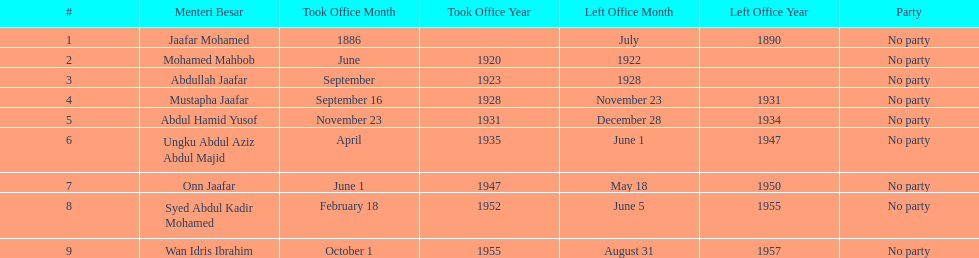Other than abullah jaafar, name someone with the same last name. Mustapha Jaafar. Would you mind parsing the complete table? {'header': ['#', 'Menteri Besar', 'Took Office Month', 'Took Office Year', 'Left Office Month', 'Left Office Year', 'Party'], 'rows': [['1', 'Jaafar Mohamed', '1886', '', 'July', '1890', 'No party'], ['2', 'Mohamed Mahbob', 'June', '1920', '1922', '', 'No party'], ['3', 'Abdullah Jaafar', 'September', '1923', '1928', '', 'No party'], ['4', 'Mustapha Jaafar', 'September 16', '1928', 'November 23', '1931', 'No party'], ['5', 'Abdul Hamid Yusof', 'November 23', '1931', 'December 28', '1934', 'No party'], ['6', 'Ungku Abdul Aziz Abdul Majid', 'April', '1935', 'June 1', '1947', 'No party'], ['7', 'Onn Jaafar', 'June 1', '1947', 'May 18', '1950', 'No party'], ['8', 'Syed Abdul Kadir Mohamed', 'February 18', '1952', 'June 5', '1955', 'No party'], ['9', 'Wan Idris Ibrahim', 'October 1', '1955', 'August 31', '1957', 'No party']]} 